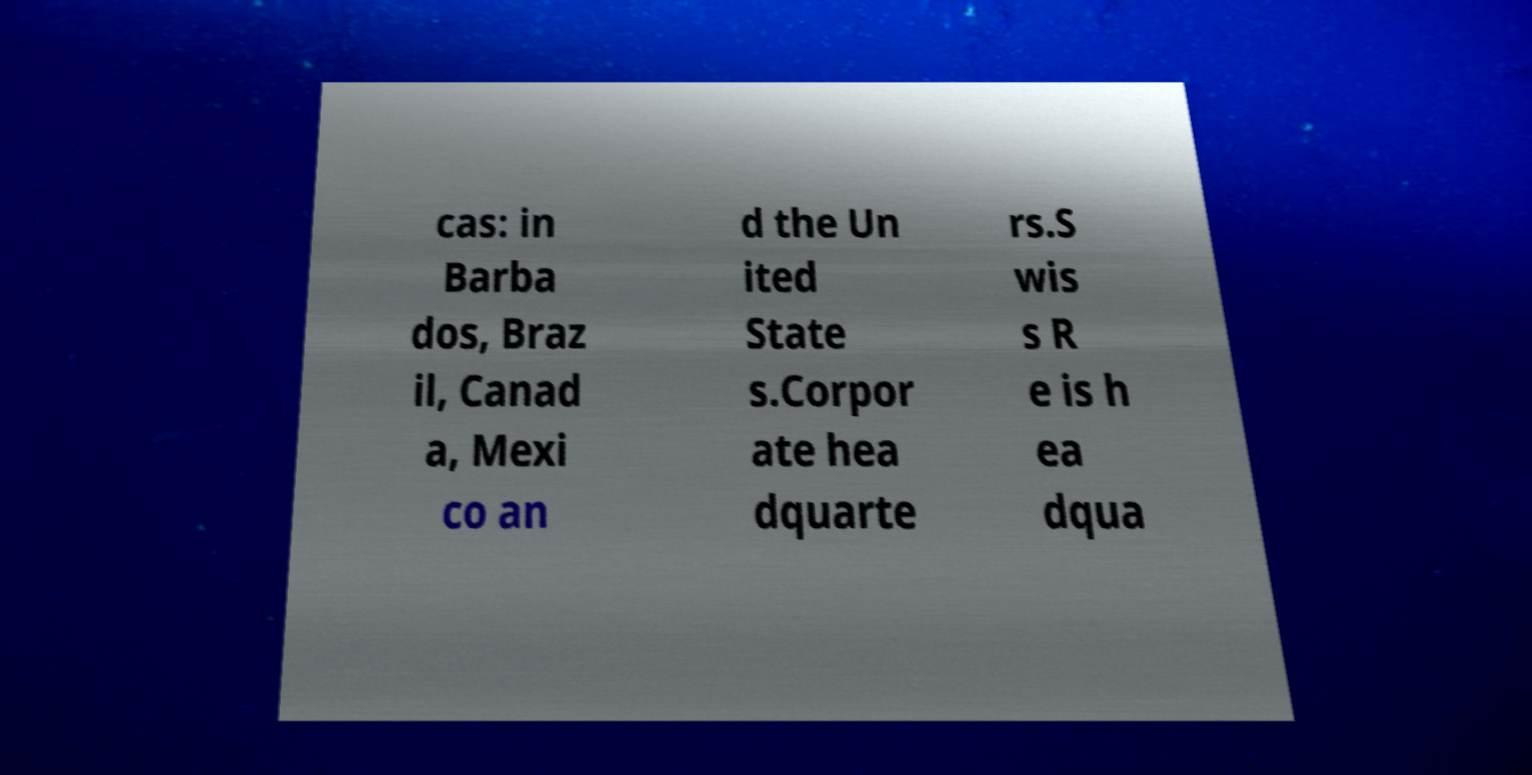I need the written content from this picture converted into text. Can you do that? cas: in Barba dos, Braz il, Canad a, Mexi co an d the Un ited State s.Corpor ate hea dquarte rs.S wis s R e is h ea dqua 